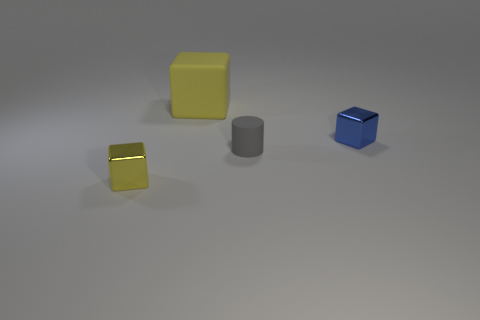There is another object that is the same color as the large matte thing; what shape is it?
Ensure brevity in your answer.  Cube. The yellow object that is made of the same material as the gray object is what shape?
Provide a succinct answer. Cube. There is a small metallic object on the left side of the yellow thing that is behind the small shiny object that is behind the tiny yellow shiny cube; what is its shape?
Make the answer very short. Cube. Are there more tiny green cubes than tiny gray matte things?
Keep it short and to the point. No. What material is the other large object that is the same shape as the yellow metal object?
Your response must be concise. Rubber. Is the small gray thing made of the same material as the large yellow thing?
Offer a terse response. Yes. Are there more cubes that are in front of the large yellow matte thing than tiny blue objects?
Your response must be concise. Yes. What material is the yellow block that is behind the small cube that is on the left side of the yellow thing behind the yellow metal cube?
Your answer should be compact. Rubber. What number of objects are either red matte things or tiny gray matte cylinders to the right of the big yellow cube?
Offer a terse response. 1. There is a matte object that is in front of the blue block; is it the same color as the matte cube?
Provide a short and direct response. No. 